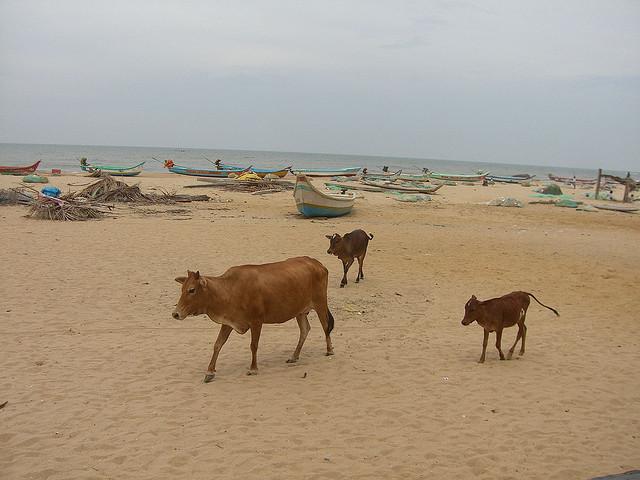How many cows are there?
Concise answer only. 3. Is this in the wild?
Quick response, please. No. Is the water calm?
Quick response, please. Yes. 